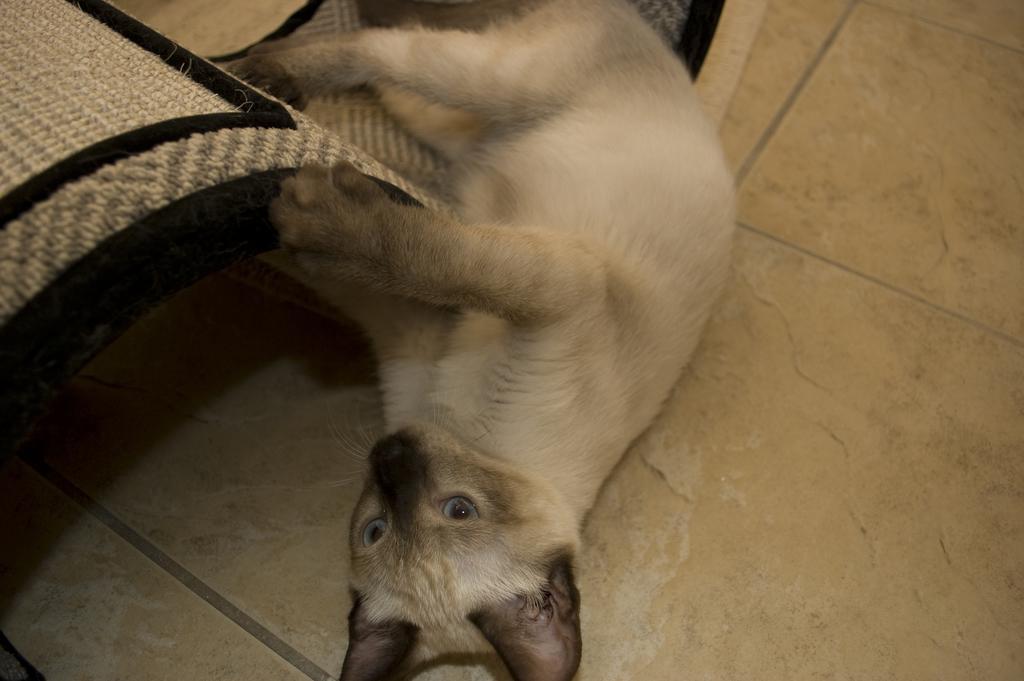In one or two sentences, can you explain what this image depicts? In the image we can see a cat lying on the floor. 